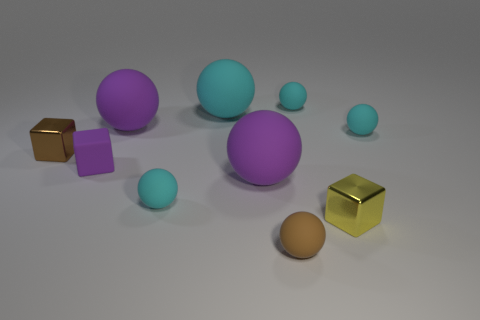Subtract all purple cylinders. How many cyan balls are left? 4 Subtract all big cyan matte spheres. How many spheres are left? 6 Subtract all brown balls. How many balls are left? 6 Subtract all purple balls. Subtract all red cylinders. How many balls are left? 5 Subtract all balls. How many objects are left? 3 Add 4 small yellow shiny blocks. How many small yellow shiny blocks exist? 5 Subtract 0 red cylinders. How many objects are left? 10 Subtract all purple rubber things. Subtract all large brown things. How many objects are left? 7 Add 3 metallic blocks. How many metallic blocks are left? 5 